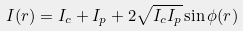Convert formula to latex. <formula><loc_0><loc_0><loc_500><loc_500>I ( { r } ) = I _ { c } + I _ { p } + 2 \sqrt { I _ { c } I _ { p } } \sin { \phi ( { r } ) }</formula> 